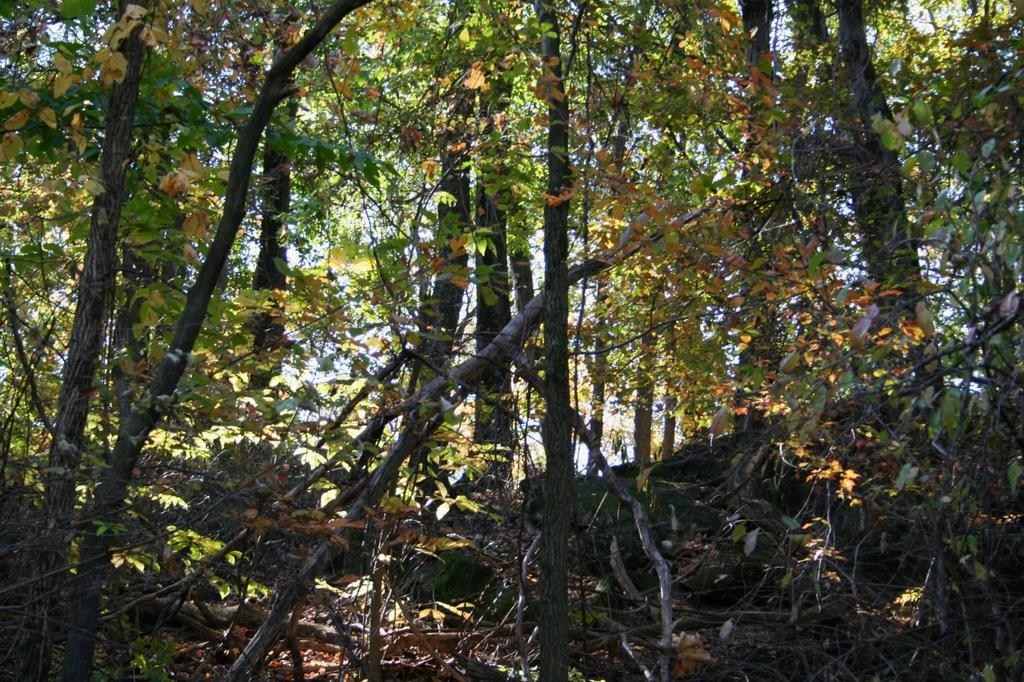What type of natural elements can be seen in the image? There are trees, rocks, and twigs in the image. What else can be seen in the image besides natural elements? There are other objects in the image. What is visible in the background of the image? The sky is visible in the background of the image. How does the family rate the digestion process of the twigs in the image? There is no family present in the image, and the digestion process of the twigs is not mentioned or depicted. 